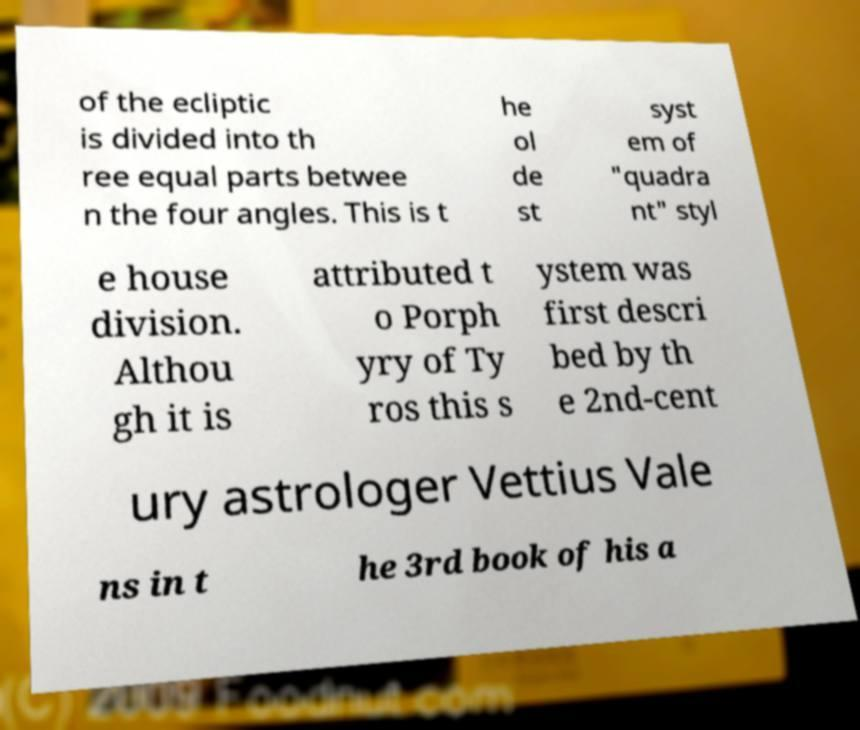For documentation purposes, I need the text within this image transcribed. Could you provide that? of the ecliptic is divided into th ree equal parts betwee n the four angles. This is t he ol de st syst em of "quadra nt" styl e house division. Althou gh it is attributed t o Porph yry of Ty ros this s ystem was first descri bed by th e 2nd-cent ury astrologer Vettius Vale ns in t he 3rd book of his a 